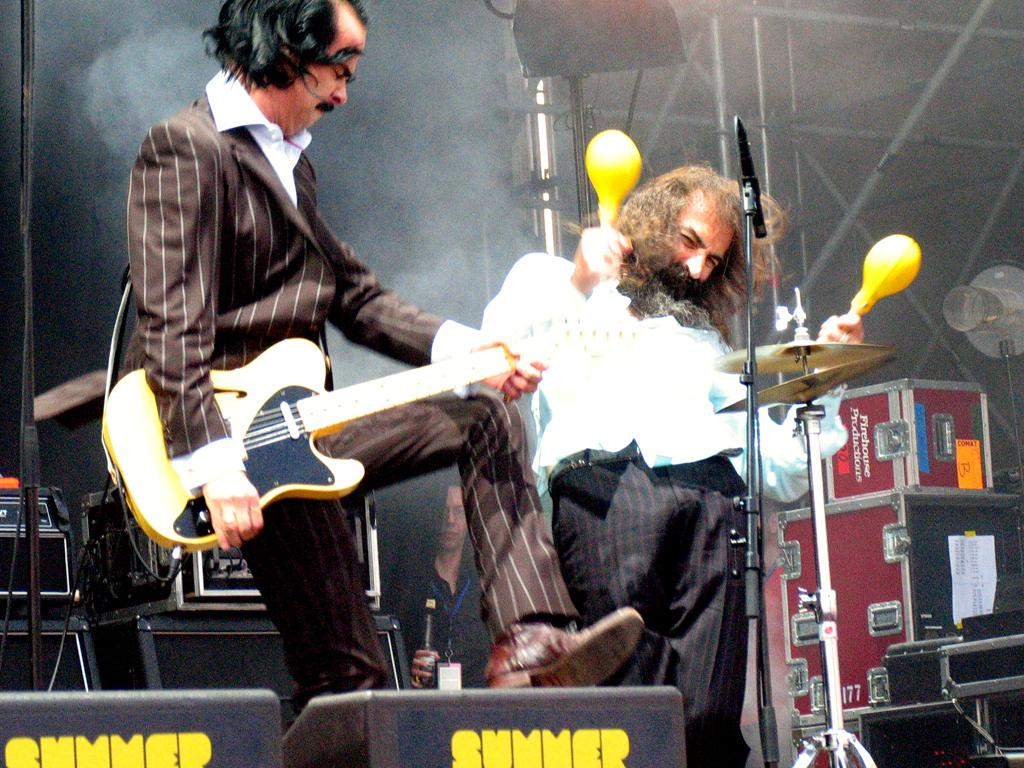How many people are in the image? There are two men in the image. What is one of the men holding? One of the men is holding a guitar. What object is present in the image that is commonly used for amplifying sound? There is a microphone in the image. Can you see any fairies playing with a cat in the image? There are no fairies or cats present in the image. Is there any indication that the man holding the guitar has just bitten into an apple? There is no apple or any indication of biting in the image. 